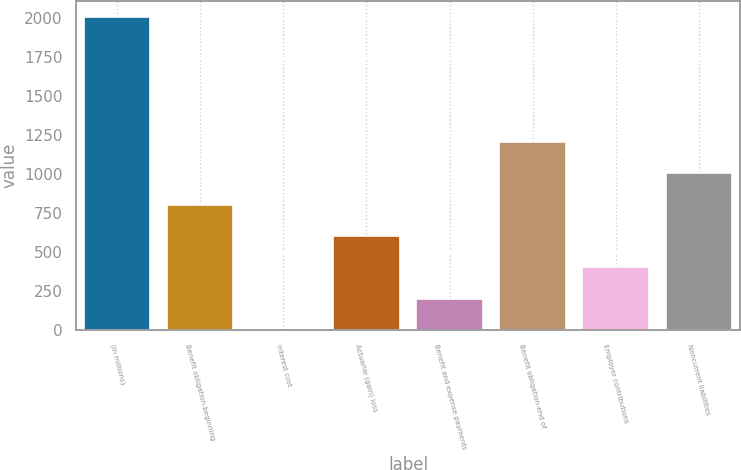Convert chart. <chart><loc_0><loc_0><loc_500><loc_500><bar_chart><fcel>(In millions)<fcel>Benefit obligation-beginning<fcel>Interest cost<fcel>Actuarial (gain) loss<fcel>Benefit and expense payments<fcel>Benefit obligation-end of<fcel>Employer contributions<fcel>Noncurrent liabilities<nl><fcel>2009<fcel>803.84<fcel>0.4<fcel>602.98<fcel>201.26<fcel>1205.56<fcel>402.12<fcel>1004.7<nl></chart> 